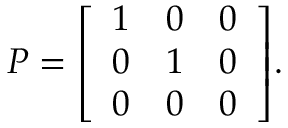<formula> <loc_0><loc_0><loc_500><loc_500>P = { \left [ \begin{array} { l l l } { 1 } & { 0 } & { 0 } \\ { 0 } & { 1 } & { 0 } \\ { 0 } & { 0 } & { 0 } \end{array} \right ] } .</formula> 